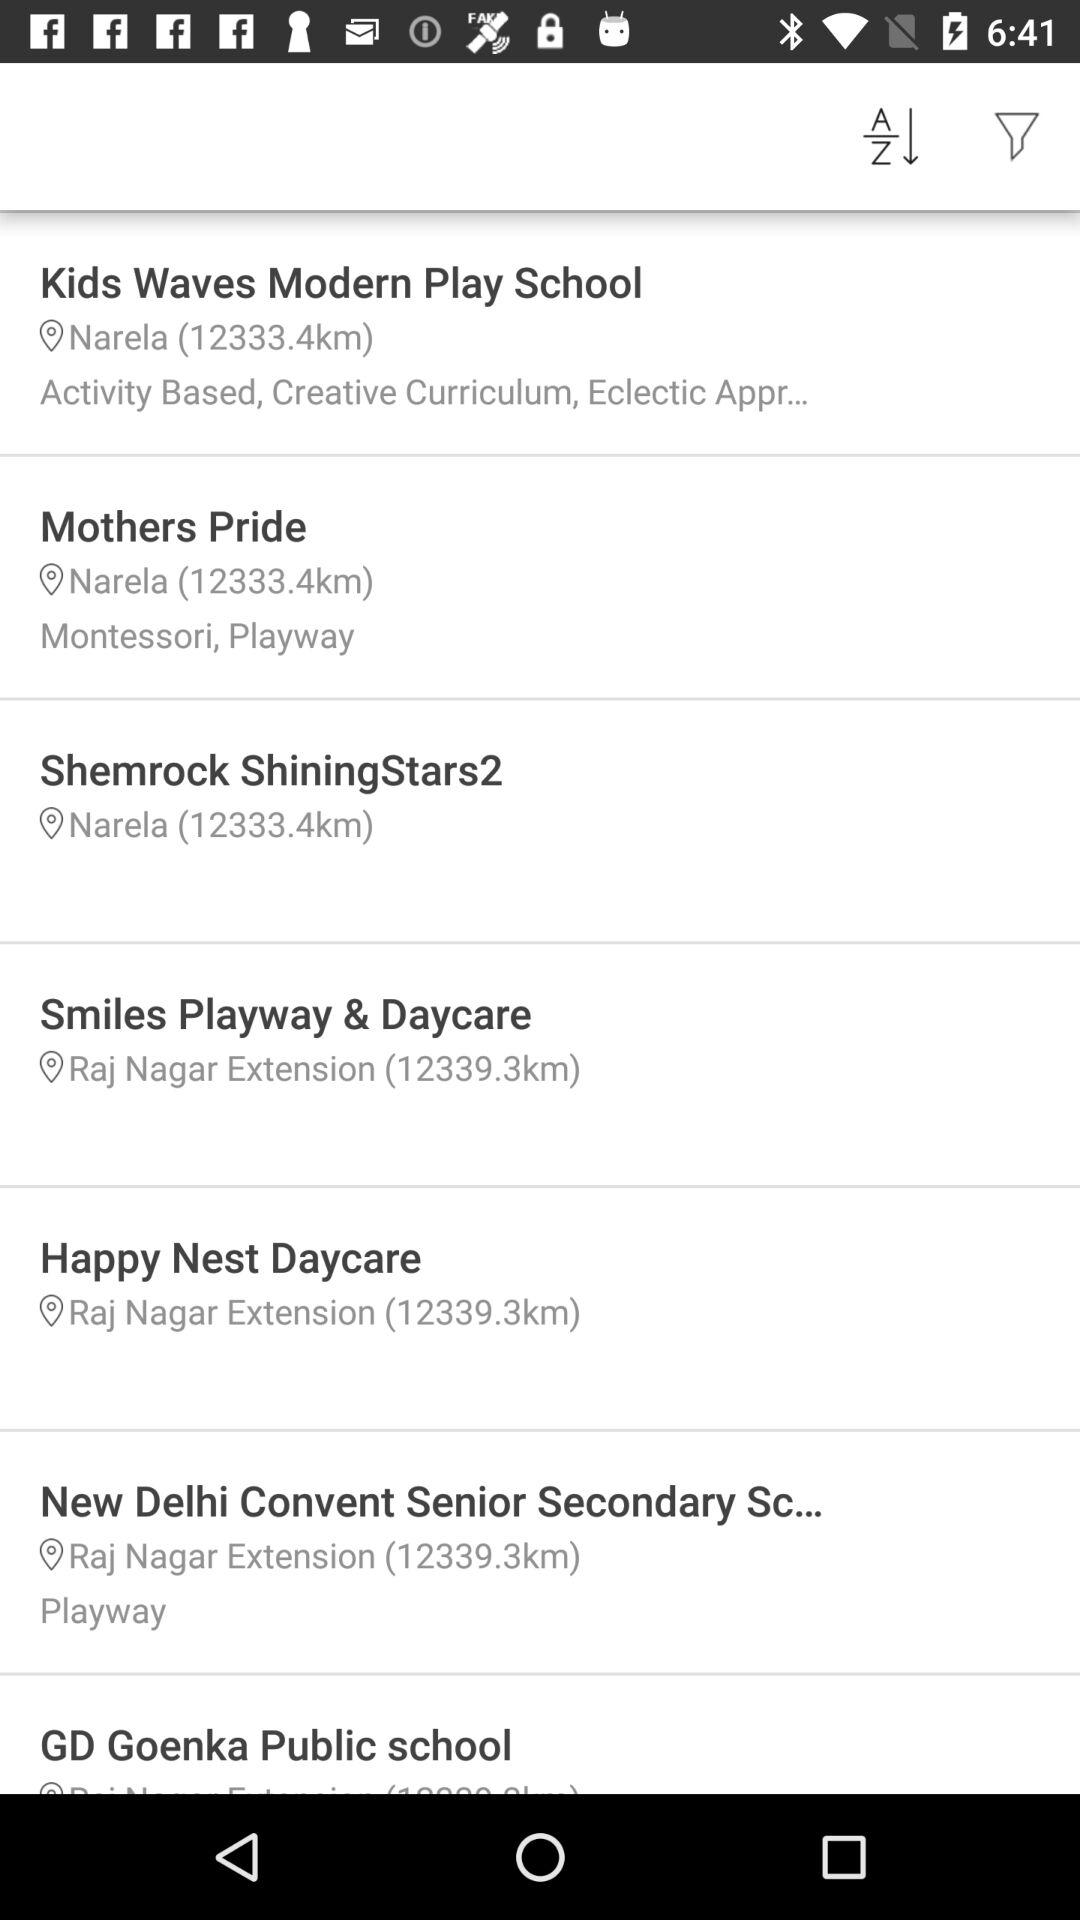How many schools are located in Narela?
Answer the question using a single word or phrase. 3 